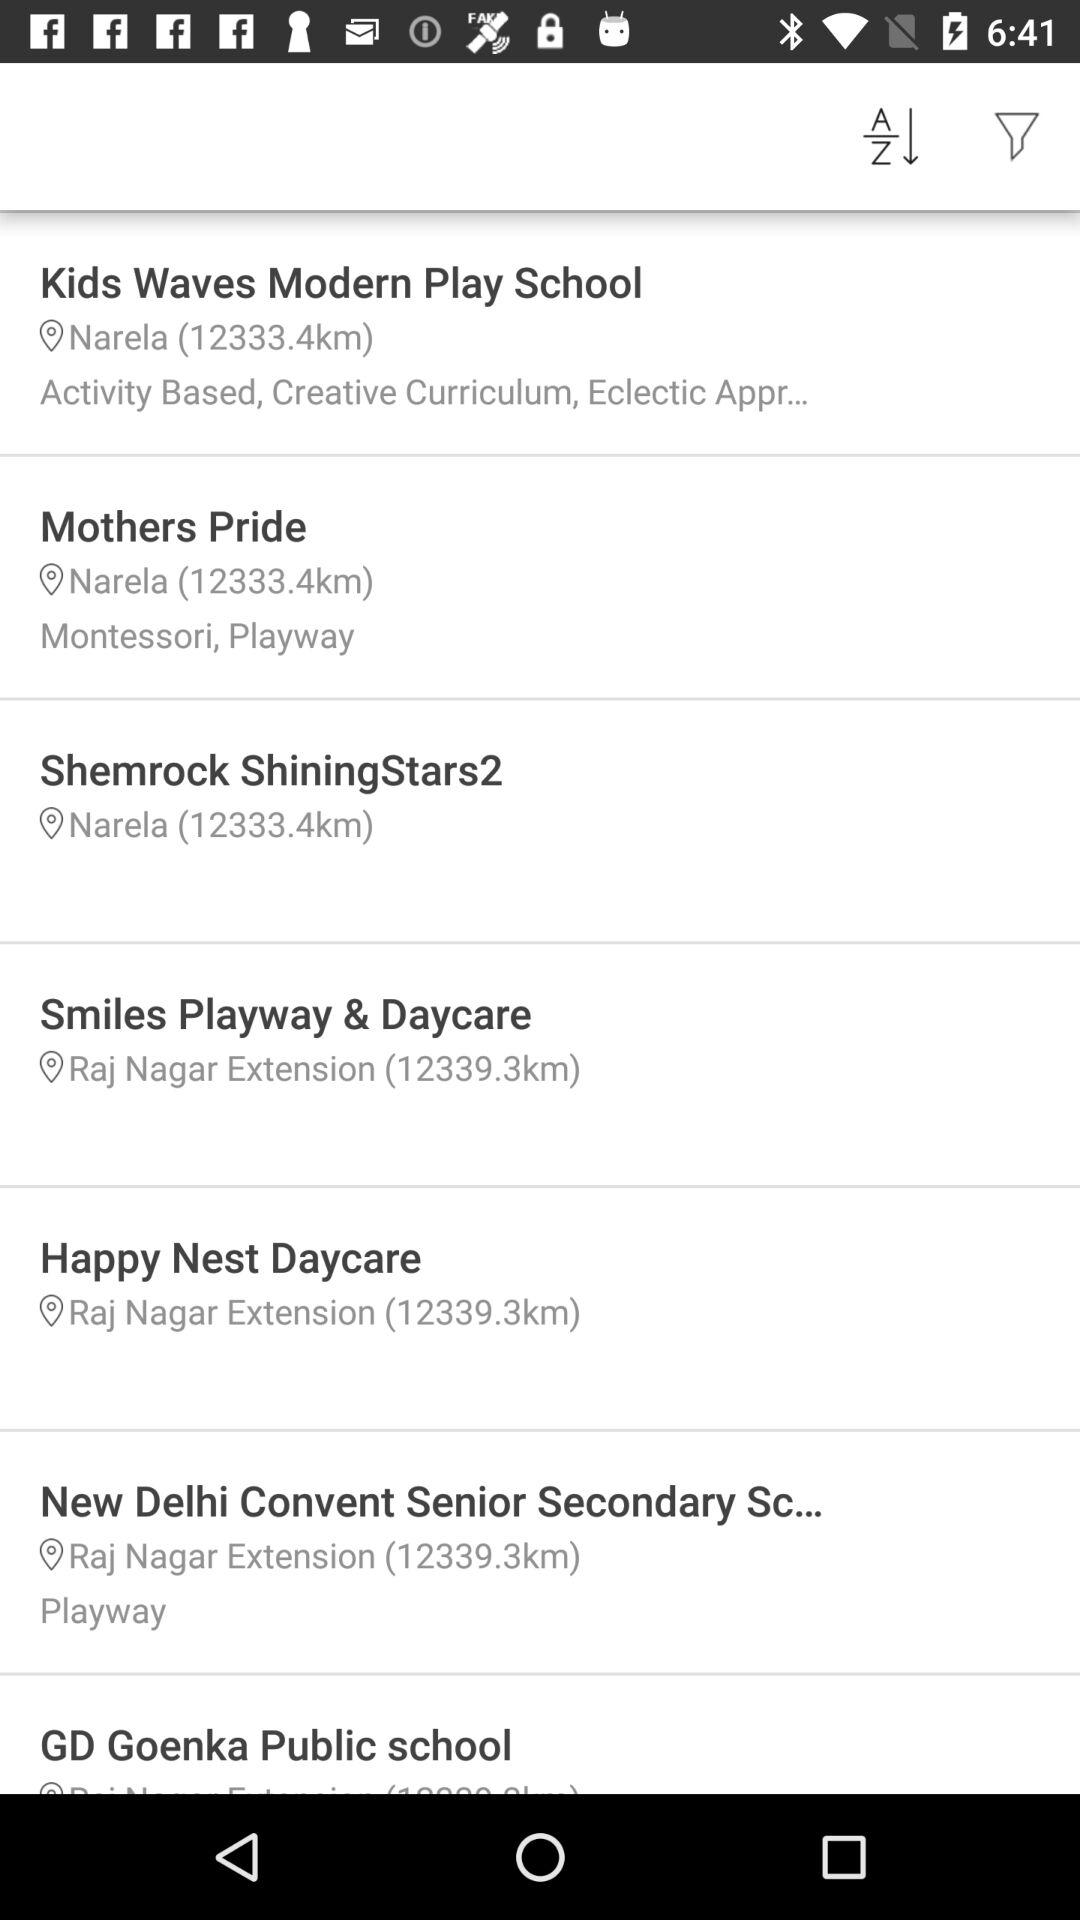How many schools are located in Narela?
Answer the question using a single word or phrase. 3 